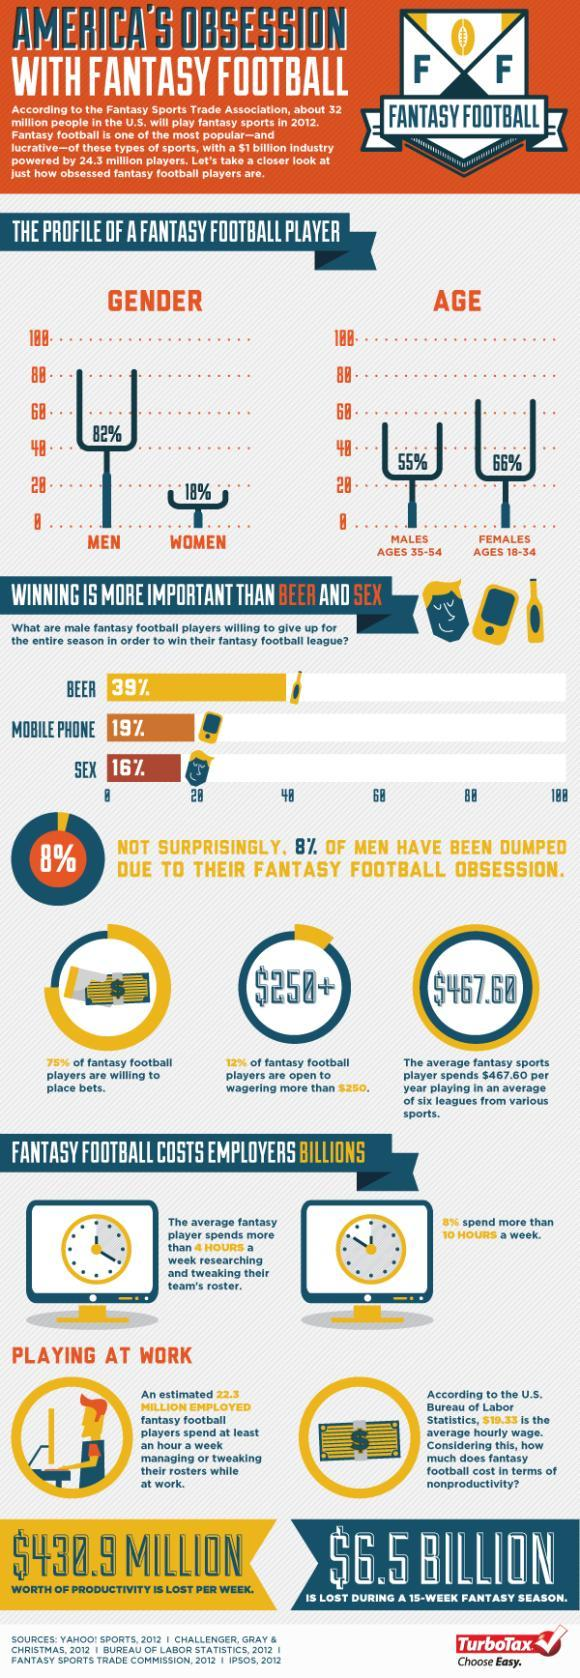What percentage of people spend not more than 10 hours a week to play the game?
Answer the question with a short phrase. 92% What percentage of fantasy football players are not willing to place bets? 25% What percentage of male fantasy football players willing to give up beer and mobile phones together for the entire season to win the fantasy football league? 58% What percentage of male fantasy football players willing to give up beer and sex together for the entire season to win the fantasy football league? 55% What percentage of fantasy football players are not open to wagering more than $250? 88% 